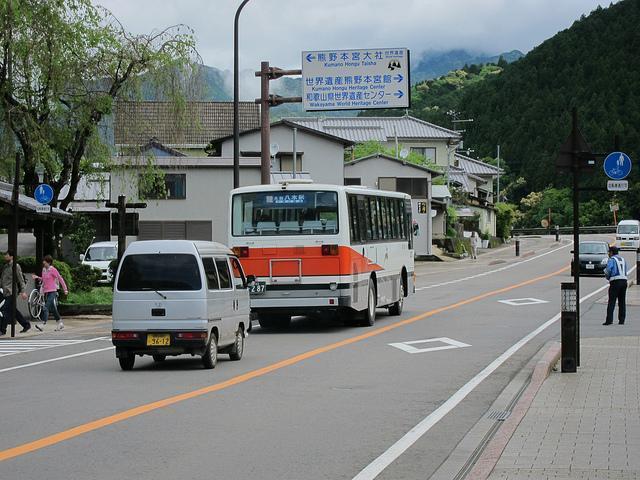How many diamonds are on the road?
Give a very brief answer. 2. How many buses are here?
Give a very brief answer. 1. How many zebras are in this picture?
Give a very brief answer. 0. 